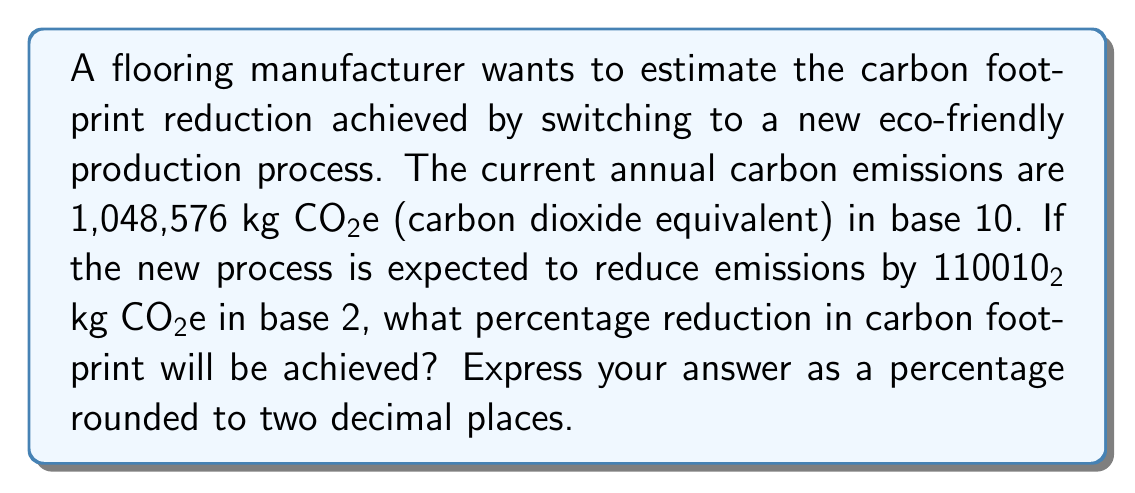Can you solve this math problem? To solve this problem, we need to follow these steps:

1. Convert the emission reduction from base 2 to base 10:
   $$110010_2 = 1 \cdot 2^5 + 1 \cdot 2^4 + 0 \cdot 2^3 + 0 \cdot 2^2 + 1 \cdot 2^1 + 0 \cdot 2^0$$
   $$= 32 + 16 + 0 + 0 + 2 + 0 = 50_{10}$$

2. Calculate the new emissions after reduction:
   $$1,048,576 - 50 = 1,048,526 \text{ kg CO₂e}$$

3. Calculate the percentage reduction:
   $$\text{Percentage reduction} = \frac{\text{Emission reduction}}{\text{Original emissions}} \times 100\%$$
   $$= \frac{50}{1,048,576} \times 100\%$$
   $$= 0.00476837\ldots\%$$

4. Round the result to two decimal places:
   $$0.00\%$$
Answer: 0.00% 